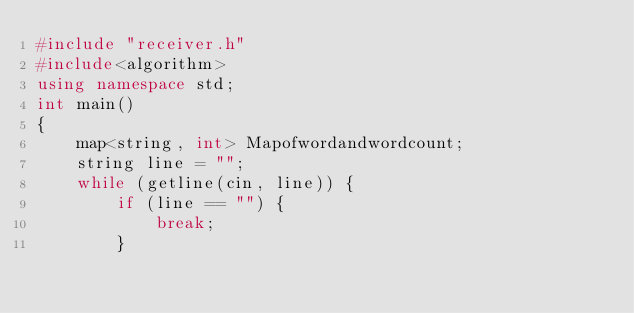Convert code to text. <code><loc_0><loc_0><loc_500><loc_500><_C++_>#include "receiver.h"
#include<algorithm>
using namespace std;
int main()
{
    map<string, int> Mapofwordandwordcount;
    string line = "";
    while (getline(cin, line)) {
        if (line == "") {
            break;
        }</code> 